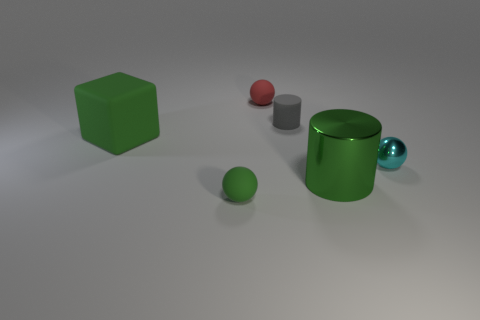Add 2 small shiny objects. How many objects exist? 8 Subtract all matte balls. How many balls are left? 1 Subtract all cubes. How many objects are left? 5 Subtract all rubber things. Subtract all large green things. How many objects are left? 0 Add 6 tiny metallic objects. How many tiny metallic objects are left? 7 Add 2 cyan objects. How many cyan objects exist? 3 Subtract 0 red cylinders. How many objects are left? 6 